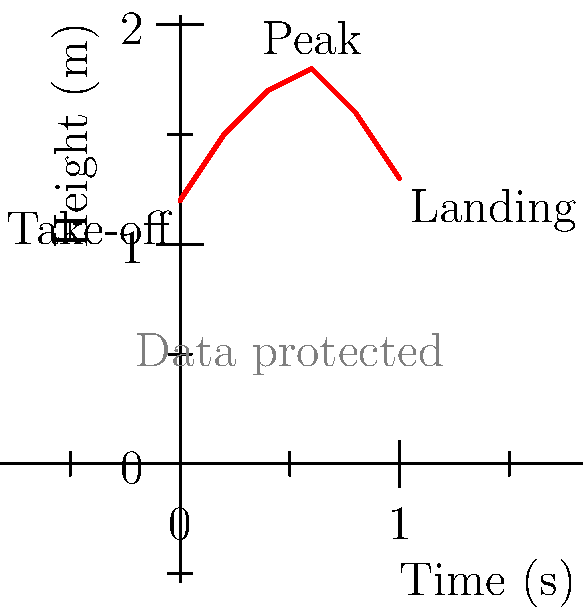Considering the center of mass trajectory during a long jump as shown in the graph, at which point does the athlete have the highest potential energy, and how does this relate to the principles of data protection in biomechanical analysis? To answer this question, we need to consider both the biomechanical aspects of the long jump and the data protection implications:

1. Biomechanical analysis:
   a. The graph shows the height of the center of mass over time during a long jump.
   b. Potential energy is directly proportional to height (PE = mgh, where m is mass, g is gravitational acceleration, and h is height).
   c. The highest point on the graph occurs at t = 0.6 seconds, with a height of 1.8 meters.
   d. Therefore, the athlete has the highest potential energy at this peak point.

2. Data protection considerations:
   a. Biomechanical analysis involves collecting sensitive personal data about an athlete's performance.
   b. This data could include precise measurements of body movements, which fall under personal data protection laws like the GDPR in the EU.
   c. The center of mass trajectory is derived from this sensitive data.
   d. Proper data protection measures must be in place to ensure the athlete's privacy and prevent unauthorized access or use of this information.

3. Relating biomechanics to data protection:
   a. The collection and analysis of such precise movement data require explicit consent from the athlete.
   b. Data minimization principle: Only necessary data should be collected and retained for the specific purpose of biomechanical analysis.
   c. Purpose limitation: The data should only be used for the agreed-upon biomechanical analysis and not for other purposes without additional consent.
   d. Data security: The motion capture data and derived analyses should be securely stored and transmitted to prevent unauthorized access.
   e. Transparency: Athletes should be informed about how their biomechanical data is being used and protected.

In conclusion, while the highest potential energy occurs at the peak of the jump (t = 0.6s, h = 1.8m), it's crucial to consider the data protection implications of collecting and analyzing such detailed biomechanical data.
Answer: Peak (t = 0.6s, h = 1.8m); requires strict data protection measures. 